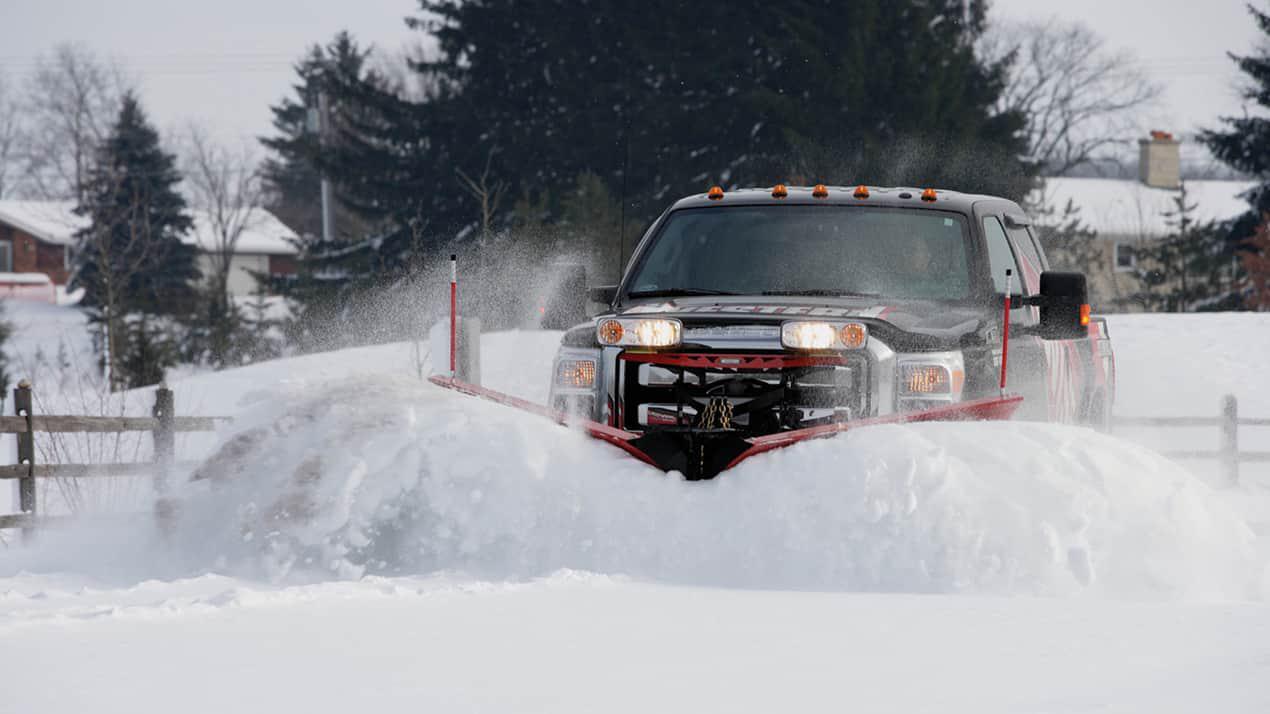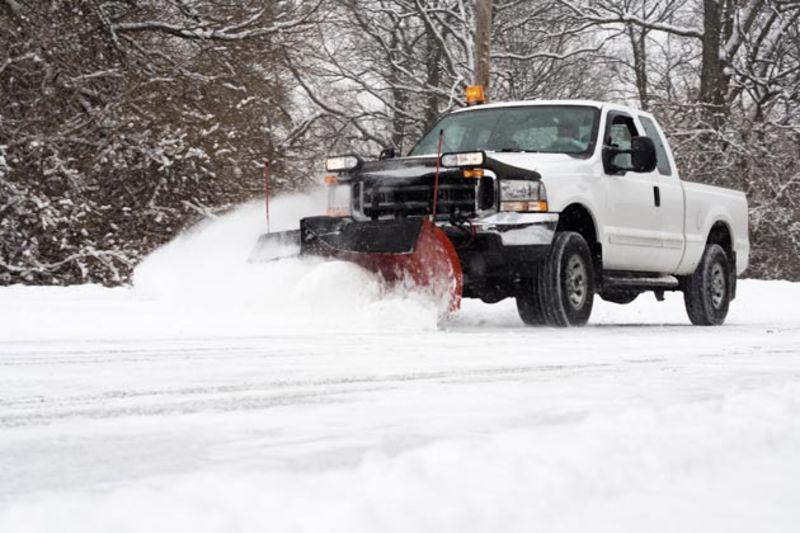The first image is the image on the left, the second image is the image on the right. Evaluate the accuracy of this statement regarding the images: "The scraper in the image on the left is red.". Is it true? Answer yes or no. No. 